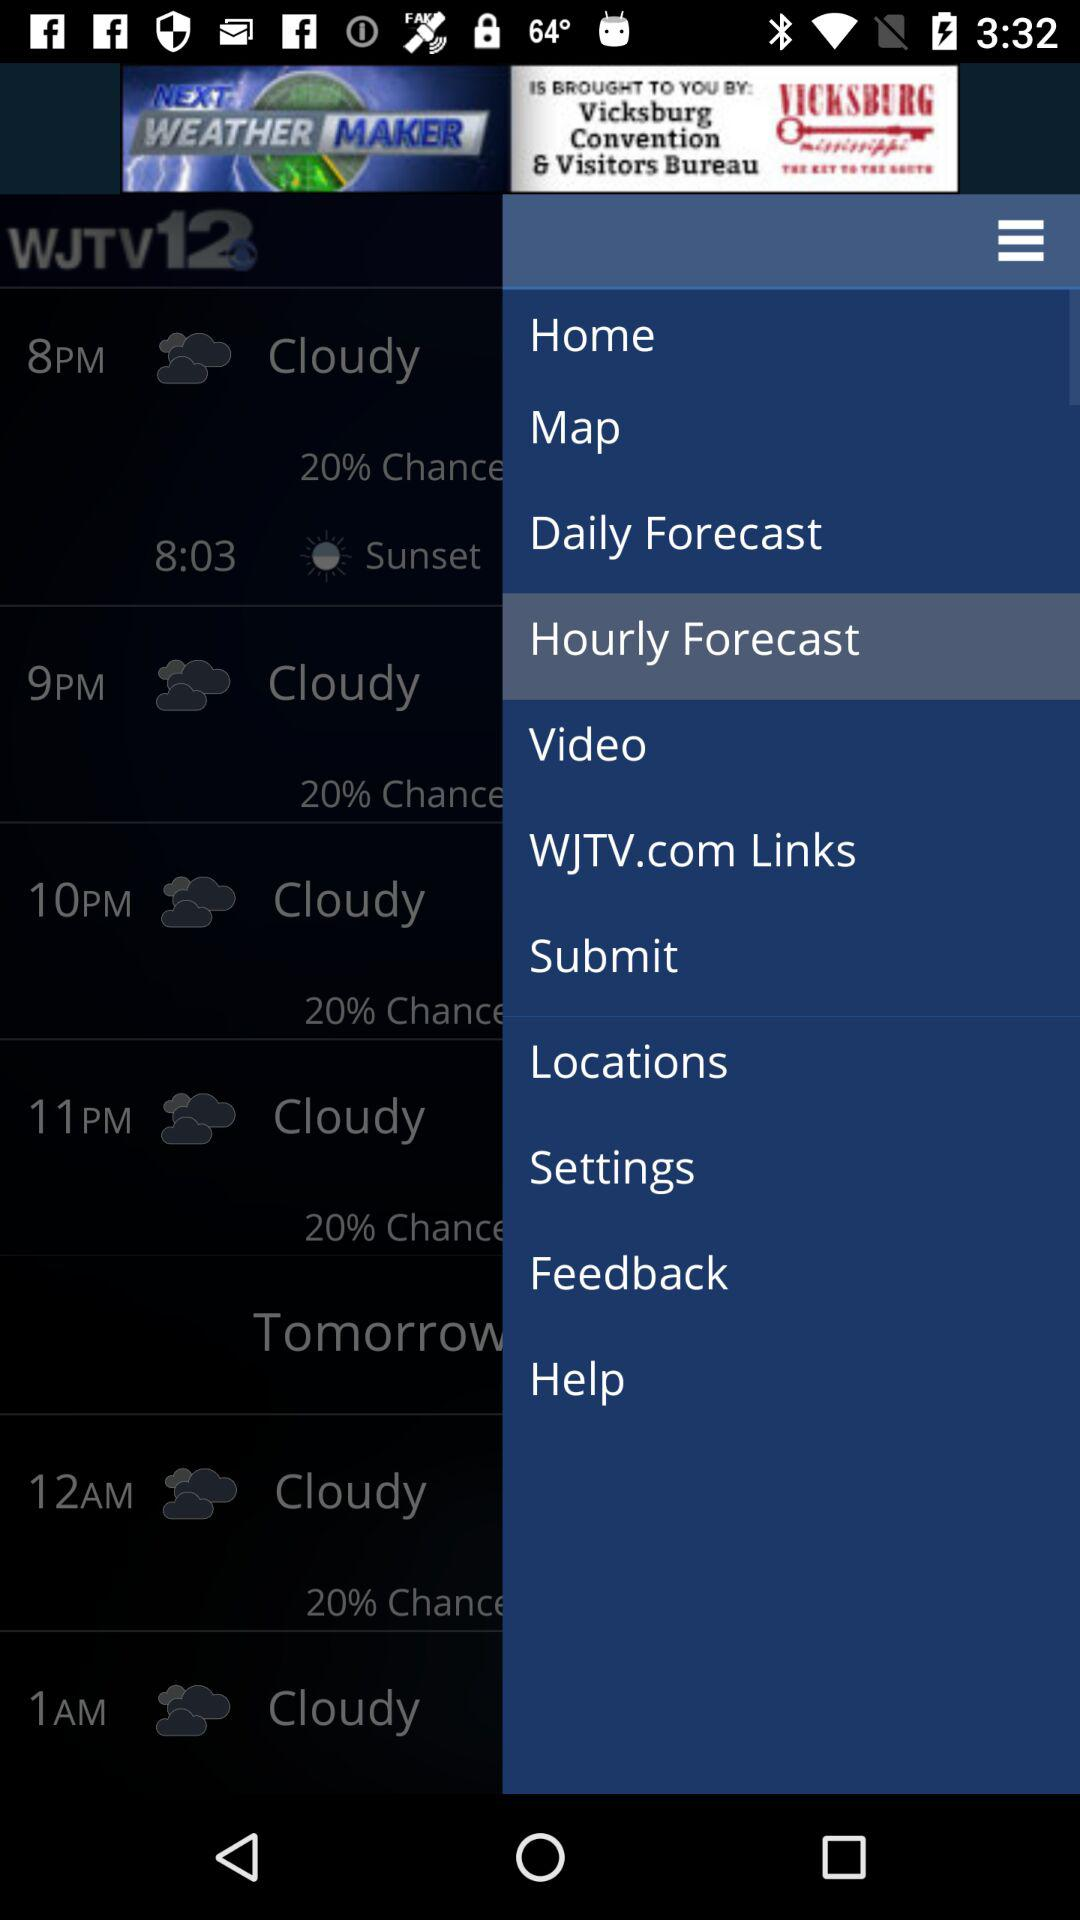How many hours from 8pm to 11pm?
Answer the question using a single word or phrase. 3 